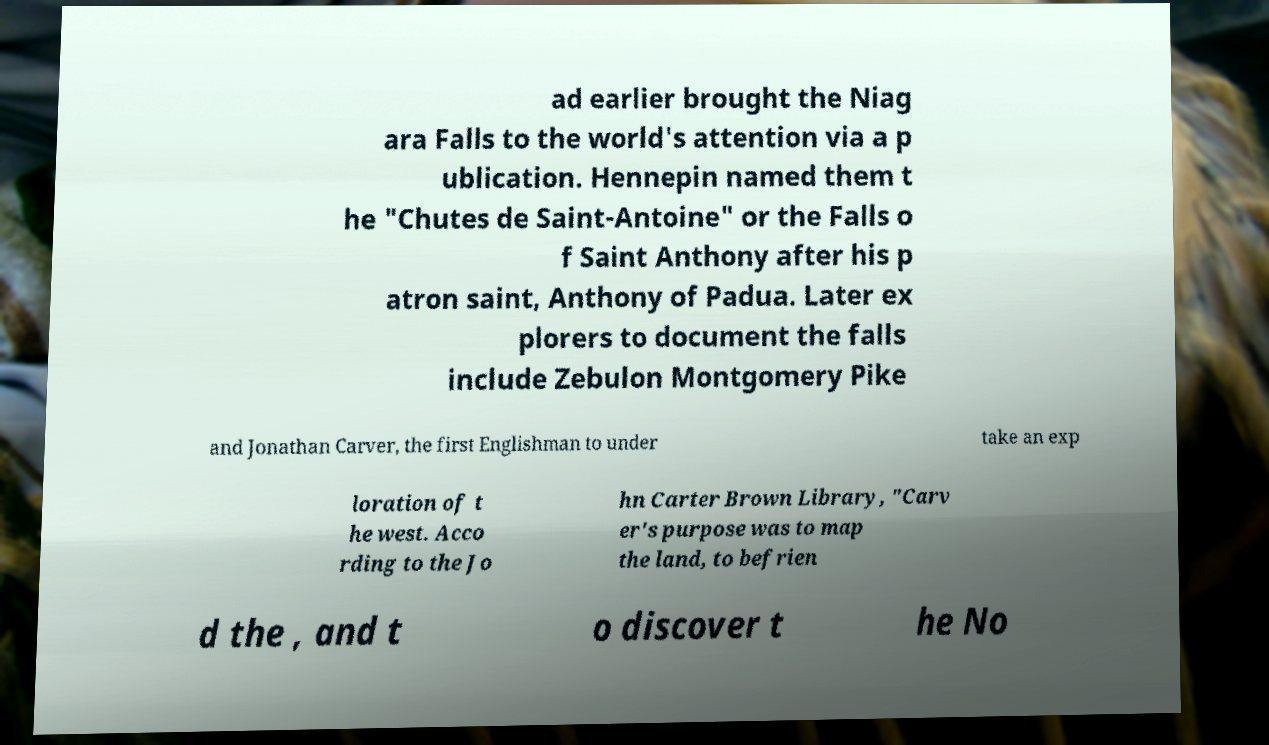Could you extract and type out the text from this image? ad earlier brought the Niag ara Falls to the world's attention via a p ublication. Hennepin named them t he "Chutes de Saint-Antoine" or the Falls o f Saint Anthony after his p atron saint, Anthony of Padua. Later ex plorers to document the falls include Zebulon Montgomery Pike and Jonathan Carver, the first Englishman to under take an exp loration of t he west. Acco rding to the Jo hn Carter Brown Library, "Carv er's purpose was to map the land, to befrien d the , and t o discover t he No 